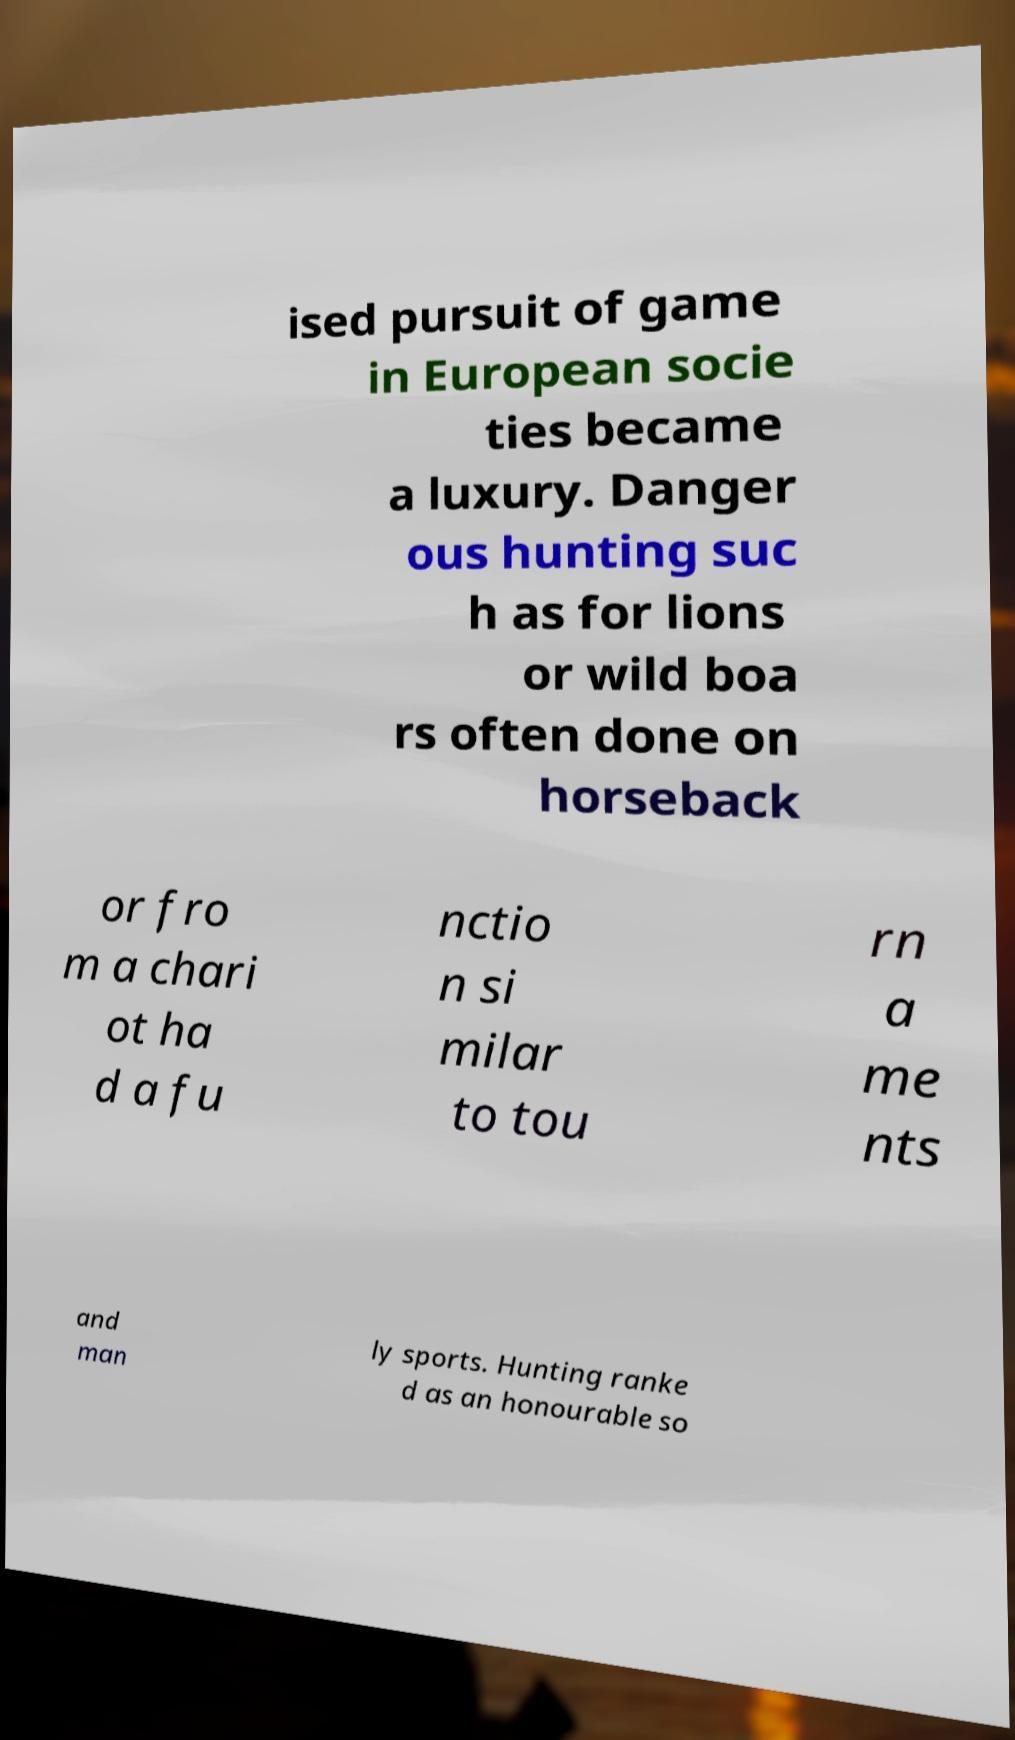I need the written content from this picture converted into text. Can you do that? ised pursuit of game in European socie ties became a luxury. Danger ous hunting suc h as for lions or wild boa rs often done on horseback or fro m a chari ot ha d a fu nctio n si milar to tou rn a me nts and man ly sports. Hunting ranke d as an honourable so 